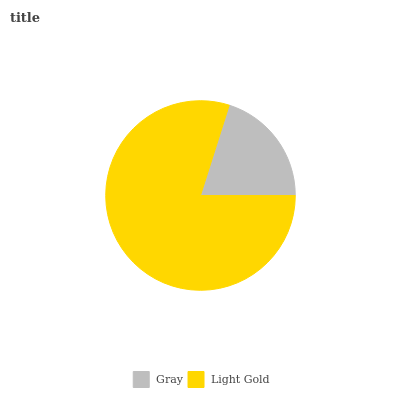Is Gray the minimum?
Answer yes or no. Yes. Is Light Gold the maximum?
Answer yes or no. Yes. Is Light Gold the minimum?
Answer yes or no. No. Is Light Gold greater than Gray?
Answer yes or no. Yes. Is Gray less than Light Gold?
Answer yes or no. Yes. Is Gray greater than Light Gold?
Answer yes or no. No. Is Light Gold less than Gray?
Answer yes or no. No. Is Light Gold the high median?
Answer yes or no. Yes. Is Gray the low median?
Answer yes or no. Yes. Is Gray the high median?
Answer yes or no. No. Is Light Gold the low median?
Answer yes or no. No. 